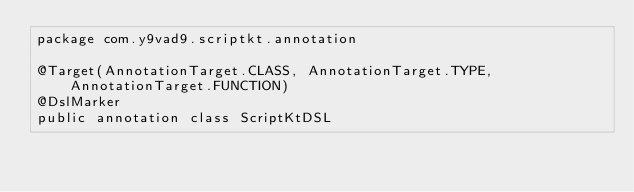Convert code to text. <code><loc_0><loc_0><loc_500><loc_500><_Kotlin_>package com.y9vad9.scriptkt.annotation

@Target(AnnotationTarget.CLASS, AnnotationTarget.TYPE, AnnotationTarget.FUNCTION)
@DslMarker
public annotation class ScriptKtDSL</code> 